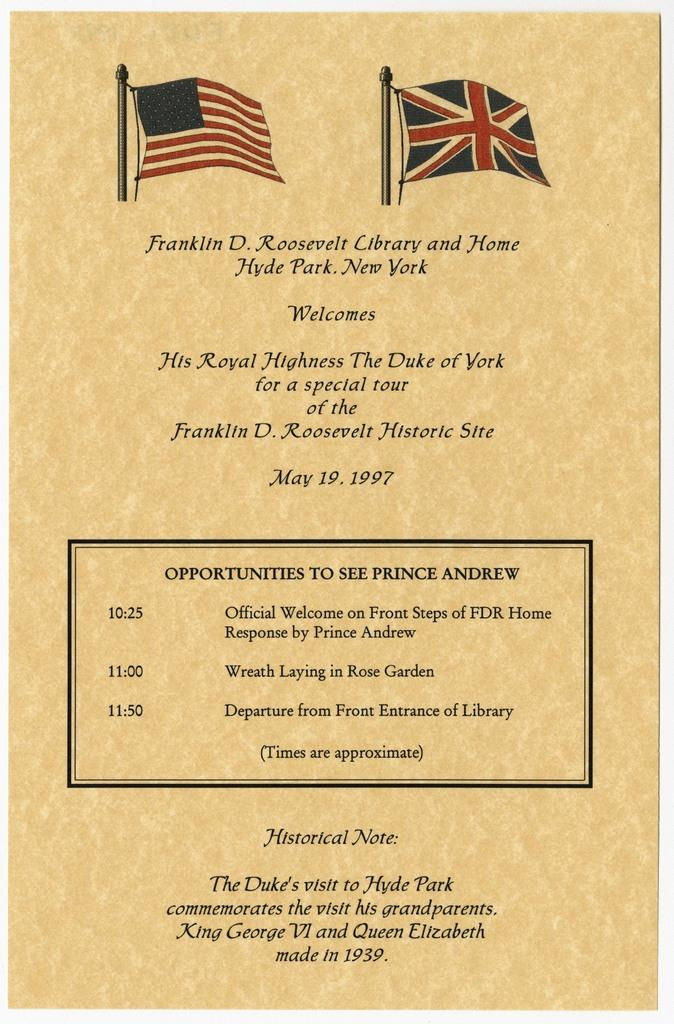What type of content can be seen in the image? There is some text and numbers in the image. What visual elements are present in the image? There are flags in the image. What is the color of the background in the image? The background of the image is creamy. Can you see a yak grazing in the stream in the image? There is no yak or stream present in the image. What type of monkey can be seen climbing the flags in the image? There are no monkeys or climbing activities depicted in the image. 